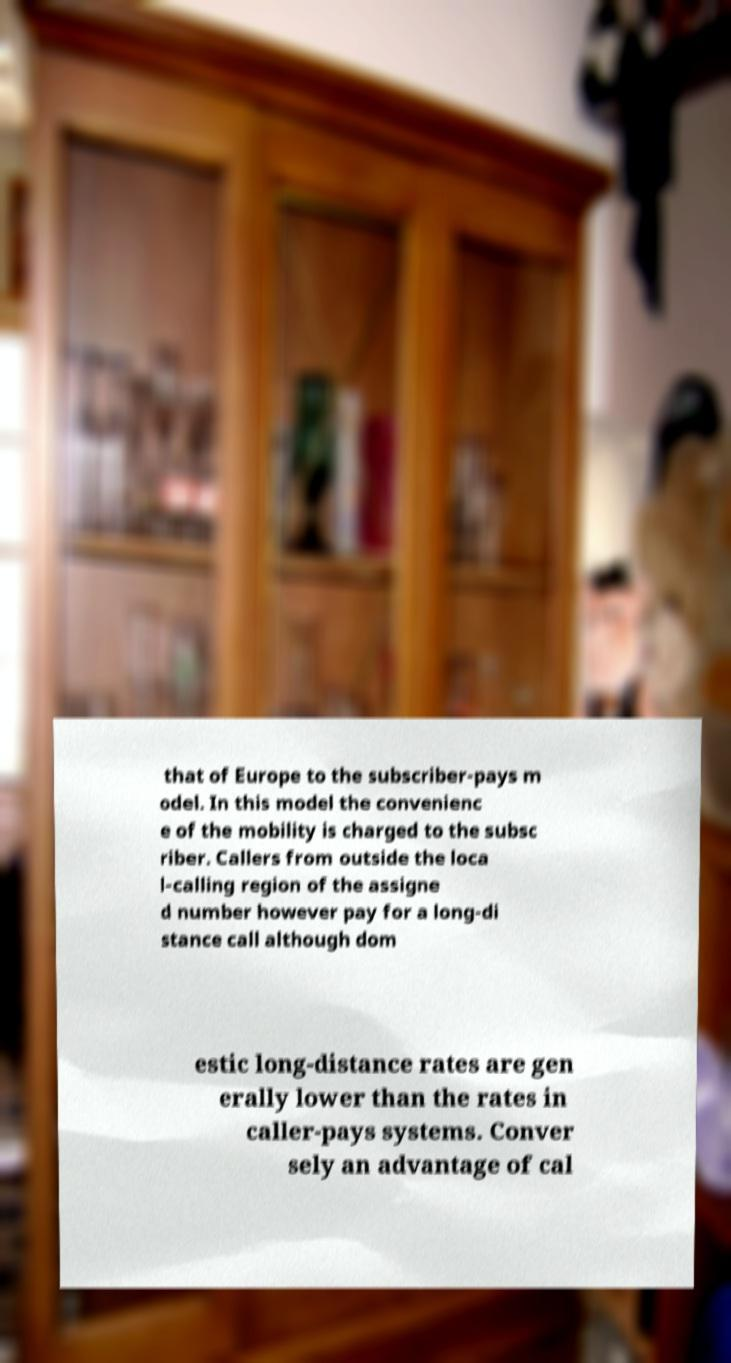Could you extract and type out the text from this image? that of Europe to the subscriber-pays m odel. In this model the convenienc e of the mobility is charged to the subsc riber. Callers from outside the loca l-calling region of the assigne d number however pay for a long-di stance call although dom estic long-distance rates are gen erally lower than the rates in caller-pays systems. Conver sely an advantage of cal 